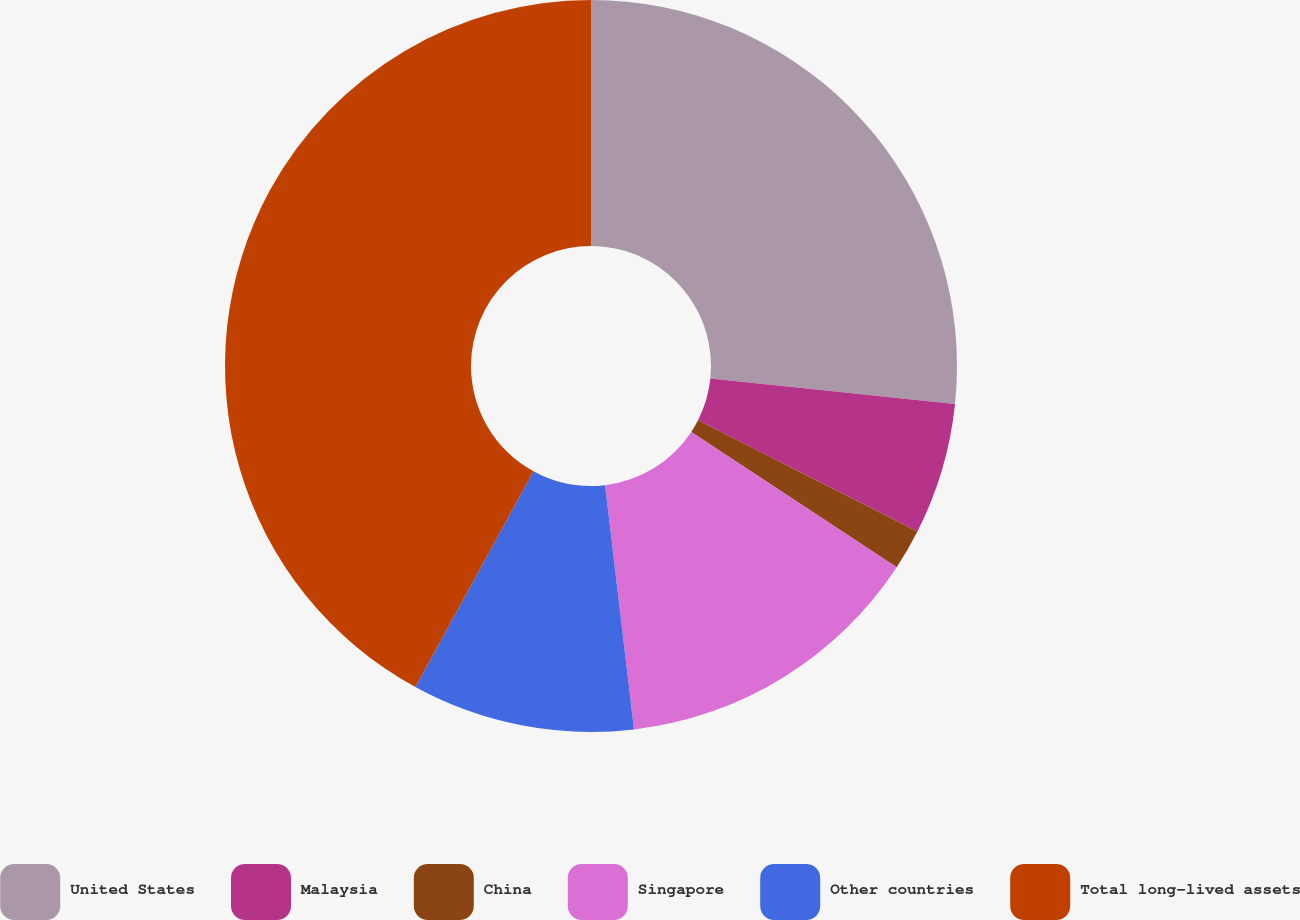Convert chart. <chart><loc_0><loc_0><loc_500><loc_500><pie_chart><fcel>United States<fcel>Malaysia<fcel>China<fcel>Singapore<fcel>Other countries<fcel>Total long-lived assets<nl><fcel>26.65%<fcel>5.82%<fcel>1.79%<fcel>13.86%<fcel>9.84%<fcel>42.03%<nl></chart> 